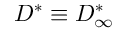Convert formula to latex. <formula><loc_0><loc_0><loc_500><loc_500>D ^ { * } \equiv D _ { \infty } ^ { * }</formula> 